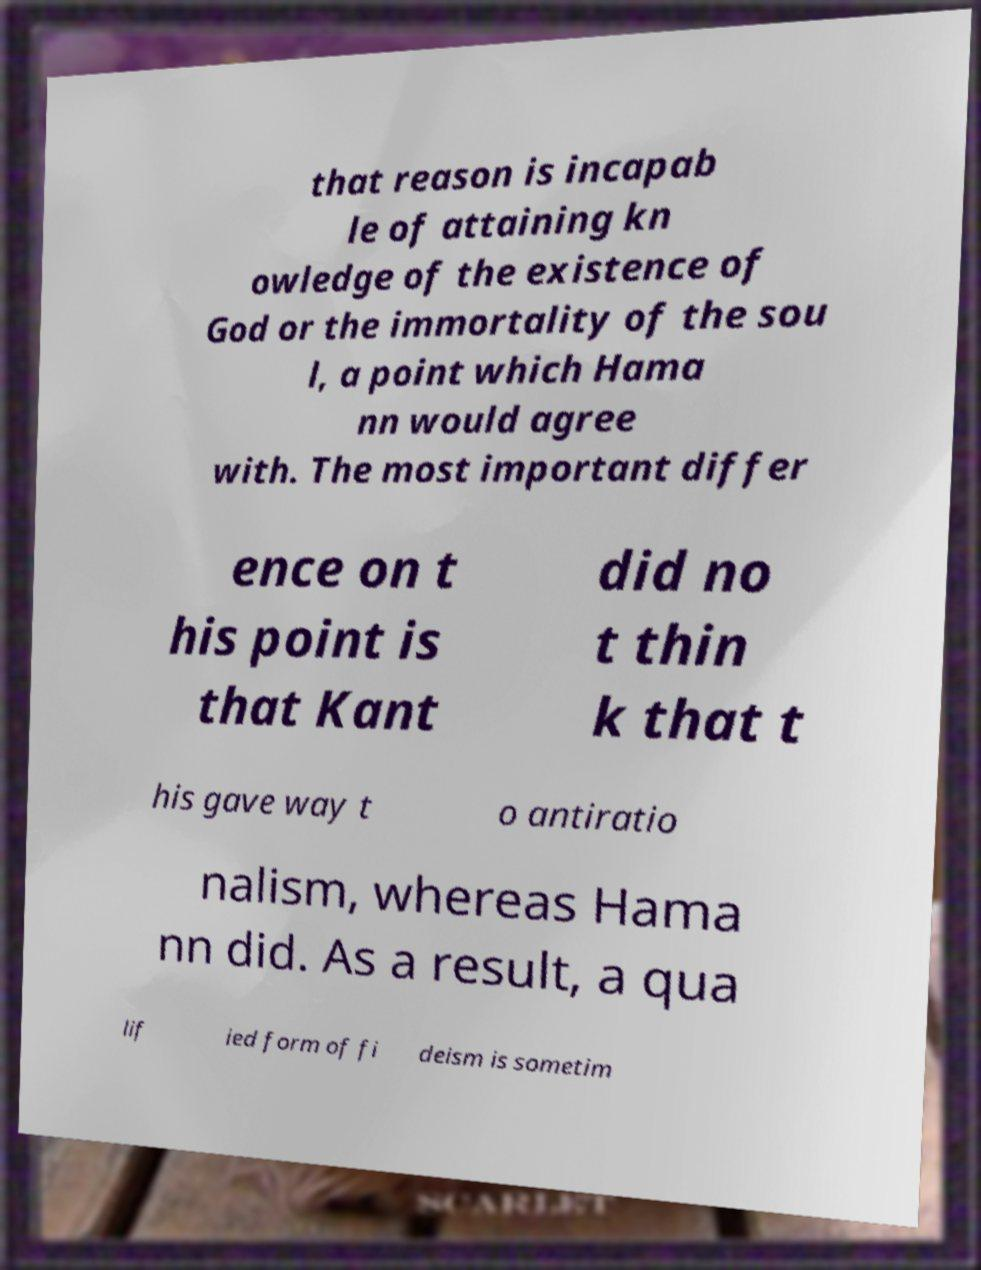For documentation purposes, I need the text within this image transcribed. Could you provide that? that reason is incapab le of attaining kn owledge of the existence of God or the immortality of the sou l, a point which Hama nn would agree with. The most important differ ence on t his point is that Kant did no t thin k that t his gave way t o antiratio nalism, whereas Hama nn did. As a result, a qua lif ied form of fi deism is sometim 